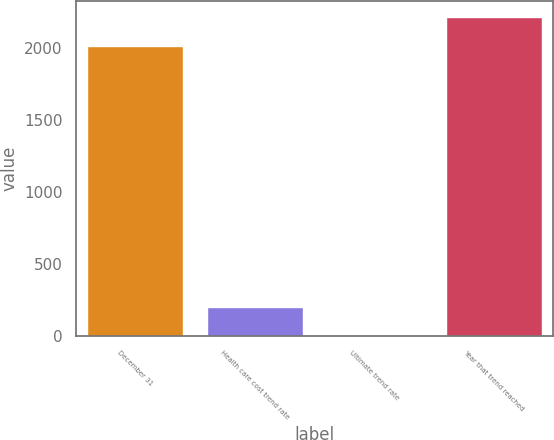<chart> <loc_0><loc_0><loc_500><loc_500><bar_chart><fcel>December 31<fcel>Health care cost trend rate<fcel>Ultimate trend rate<fcel>Year that trend reached<nl><fcel>2013<fcel>206.3<fcel>5<fcel>2214.3<nl></chart> 